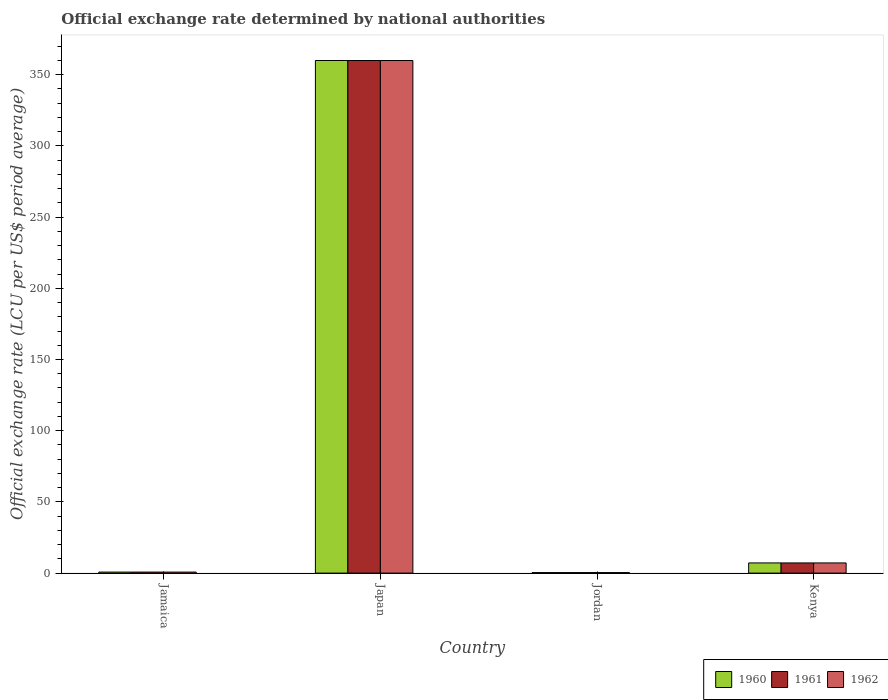How many different coloured bars are there?
Make the answer very short. 3. How many groups of bars are there?
Offer a terse response. 4. Are the number of bars on each tick of the X-axis equal?
Provide a succinct answer. Yes. How many bars are there on the 2nd tick from the right?
Provide a short and direct response. 3. What is the label of the 3rd group of bars from the left?
Make the answer very short. Jordan. In how many cases, is the number of bars for a given country not equal to the number of legend labels?
Your answer should be very brief. 0. What is the official exchange rate in 1962 in Jamaica?
Keep it short and to the point. 0.71. Across all countries, what is the maximum official exchange rate in 1960?
Give a very brief answer. 360. Across all countries, what is the minimum official exchange rate in 1961?
Keep it short and to the point. 0.36. In which country was the official exchange rate in 1962 minimum?
Provide a succinct answer. Jordan. What is the total official exchange rate in 1962 in the graph?
Keep it short and to the point. 368.21. What is the difference between the official exchange rate in 1960 in Jordan and that in Kenya?
Make the answer very short. -6.79. What is the difference between the official exchange rate in 1962 in Kenya and the official exchange rate in 1961 in Jordan?
Your answer should be compact. 6.79. What is the average official exchange rate in 1960 per country?
Offer a terse response. 92.05. What is the difference between the official exchange rate of/in 1962 and official exchange rate of/in 1960 in Jamaica?
Your answer should be very brief. 0. What is the ratio of the official exchange rate in 1961 in Japan to that in Jordan?
Give a very brief answer. 1008. Is the official exchange rate in 1961 in Jamaica less than that in Kenya?
Your answer should be very brief. Yes. What is the difference between the highest and the second highest official exchange rate in 1960?
Your answer should be compact. 359.29. What is the difference between the highest and the lowest official exchange rate in 1961?
Your response must be concise. 359.64. Is it the case that in every country, the sum of the official exchange rate in 1962 and official exchange rate in 1961 is greater than the official exchange rate in 1960?
Your answer should be compact. Yes. How many bars are there?
Your response must be concise. 12. Are all the bars in the graph horizontal?
Offer a very short reply. No. How many countries are there in the graph?
Ensure brevity in your answer.  4. Does the graph contain any zero values?
Offer a very short reply. No. Where does the legend appear in the graph?
Offer a terse response. Bottom right. How many legend labels are there?
Give a very brief answer. 3. How are the legend labels stacked?
Keep it short and to the point. Horizontal. What is the title of the graph?
Ensure brevity in your answer.  Official exchange rate determined by national authorities. What is the label or title of the X-axis?
Your answer should be compact. Country. What is the label or title of the Y-axis?
Give a very brief answer. Official exchange rate (LCU per US$ period average). What is the Official exchange rate (LCU per US$ period average) of 1960 in Jamaica?
Provide a succinct answer. 0.71. What is the Official exchange rate (LCU per US$ period average) of 1961 in Jamaica?
Your response must be concise. 0.71. What is the Official exchange rate (LCU per US$ period average) of 1962 in Jamaica?
Ensure brevity in your answer.  0.71. What is the Official exchange rate (LCU per US$ period average) in 1960 in Japan?
Make the answer very short. 360. What is the Official exchange rate (LCU per US$ period average) in 1961 in Japan?
Give a very brief answer. 360. What is the Official exchange rate (LCU per US$ period average) in 1962 in Japan?
Provide a succinct answer. 360. What is the Official exchange rate (LCU per US$ period average) in 1960 in Jordan?
Make the answer very short. 0.36. What is the Official exchange rate (LCU per US$ period average) in 1961 in Jordan?
Offer a terse response. 0.36. What is the Official exchange rate (LCU per US$ period average) of 1962 in Jordan?
Keep it short and to the point. 0.36. What is the Official exchange rate (LCU per US$ period average) of 1960 in Kenya?
Give a very brief answer. 7.14. What is the Official exchange rate (LCU per US$ period average) in 1961 in Kenya?
Ensure brevity in your answer.  7.14. What is the Official exchange rate (LCU per US$ period average) of 1962 in Kenya?
Ensure brevity in your answer.  7.14. Across all countries, what is the maximum Official exchange rate (LCU per US$ period average) of 1960?
Offer a terse response. 360. Across all countries, what is the maximum Official exchange rate (LCU per US$ period average) in 1961?
Ensure brevity in your answer.  360. Across all countries, what is the maximum Official exchange rate (LCU per US$ period average) of 1962?
Make the answer very short. 360. Across all countries, what is the minimum Official exchange rate (LCU per US$ period average) in 1960?
Give a very brief answer. 0.36. Across all countries, what is the minimum Official exchange rate (LCU per US$ period average) in 1961?
Ensure brevity in your answer.  0.36. Across all countries, what is the minimum Official exchange rate (LCU per US$ period average) of 1962?
Offer a very short reply. 0.36. What is the total Official exchange rate (LCU per US$ period average) in 1960 in the graph?
Your answer should be compact. 368.21. What is the total Official exchange rate (LCU per US$ period average) in 1961 in the graph?
Offer a very short reply. 368.21. What is the total Official exchange rate (LCU per US$ period average) in 1962 in the graph?
Your answer should be very brief. 368.21. What is the difference between the Official exchange rate (LCU per US$ period average) in 1960 in Jamaica and that in Japan?
Your answer should be compact. -359.29. What is the difference between the Official exchange rate (LCU per US$ period average) in 1961 in Jamaica and that in Japan?
Provide a short and direct response. -359.29. What is the difference between the Official exchange rate (LCU per US$ period average) of 1962 in Jamaica and that in Japan?
Provide a succinct answer. -359.29. What is the difference between the Official exchange rate (LCU per US$ period average) of 1960 in Jamaica and that in Jordan?
Provide a short and direct response. 0.36. What is the difference between the Official exchange rate (LCU per US$ period average) in 1961 in Jamaica and that in Jordan?
Your answer should be compact. 0.36. What is the difference between the Official exchange rate (LCU per US$ period average) in 1962 in Jamaica and that in Jordan?
Your answer should be very brief. 0.36. What is the difference between the Official exchange rate (LCU per US$ period average) in 1960 in Jamaica and that in Kenya?
Ensure brevity in your answer.  -6.43. What is the difference between the Official exchange rate (LCU per US$ period average) of 1961 in Jamaica and that in Kenya?
Your answer should be compact. -6.43. What is the difference between the Official exchange rate (LCU per US$ period average) in 1962 in Jamaica and that in Kenya?
Give a very brief answer. -6.43. What is the difference between the Official exchange rate (LCU per US$ period average) in 1960 in Japan and that in Jordan?
Offer a terse response. 359.64. What is the difference between the Official exchange rate (LCU per US$ period average) of 1961 in Japan and that in Jordan?
Make the answer very short. 359.64. What is the difference between the Official exchange rate (LCU per US$ period average) in 1962 in Japan and that in Jordan?
Your answer should be compact. 359.64. What is the difference between the Official exchange rate (LCU per US$ period average) in 1960 in Japan and that in Kenya?
Make the answer very short. 352.86. What is the difference between the Official exchange rate (LCU per US$ period average) of 1961 in Japan and that in Kenya?
Offer a terse response. 352.86. What is the difference between the Official exchange rate (LCU per US$ period average) in 1962 in Japan and that in Kenya?
Your answer should be compact. 352.86. What is the difference between the Official exchange rate (LCU per US$ period average) in 1960 in Jordan and that in Kenya?
Ensure brevity in your answer.  -6.79. What is the difference between the Official exchange rate (LCU per US$ period average) of 1961 in Jordan and that in Kenya?
Make the answer very short. -6.79. What is the difference between the Official exchange rate (LCU per US$ period average) of 1962 in Jordan and that in Kenya?
Make the answer very short. -6.79. What is the difference between the Official exchange rate (LCU per US$ period average) of 1960 in Jamaica and the Official exchange rate (LCU per US$ period average) of 1961 in Japan?
Provide a short and direct response. -359.29. What is the difference between the Official exchange rate (LCU per US$ period average) in 1960 in Jamaica and the Official exchange rate (LCU per US$ period average) in 1962 in Japan?
Provide a short and direct response. -359.29. What is the difference between the Official exchange rate (LCU per US$ period average) in 1961 in Jamaica and the Official exchange rate (LCU per US$ period average) in 1962 in Japan?
Your response must be concise. -359.29. What is the difference between the Official exchange rate (LCU per US$ period average) of 1960 in Jamaica and the Official exchange rate (LCU per US$ period average) of 1961 in Jordan?
Make the answer very short. 0.36. What is the difference between the Official exchange rate (LCU per US$ period average) in 1960 in Jamaica and the Official exchange rate (LCU per US$ period average) in 1962 in Jordan?
Provide a short and direct response. 0.36. What is the difference between the Official exchange rate (LCU per US$ period average) of 1961 in Jamaica and the Official exchange rate (LCU per US$ period average) of 1962 in Jordan?
Give a very brief answer. 0.36. What is the difference between the Official exchange rate (LCU per US$ period average) of 1960 in Jamaica and the Official exchange rate (LCU per US$ period average) of 1961 in Kenya?
Give a very brief answer. -6.43. What is the difference between the Official exchange rate (LCU per US$ period average) in 1960 in Jamaica and the Official exchange rate (LCU per US$ period average) in 1962 in Kenya?
Your response must be concise. -6.43. What is the difference between the Official exchange rate (LCU per US$ period average) of 1961 in Jamaica and the Official exchange rate (LCU per US$ period average) of 1962 in Kenya?
Provide a short and direct response. -6.43. What is the difference between the Official exchange rate (LCU per US$ period average) in 1960 in Japan and the Official exchange rate (LCU per US$ period average) in 1961 in Jordan?
Offer a very short reply. 359.64. What is the difference between the Official exchange rate (LCU per US$ period average) of 1960 in Japan and the Official exchange rate (LCU per US$ period average) of 1962 in Jordan?
Your response must be concise. 359.64. What is the difference between the Official exchange rate (LCU per US$ period average) in 1961 in Japan and the Official exchange rate (LCU per US$ period average) in 1962 in Jordan?
Provide a short and direct response. 359.64. What is the difference between the Official exchange rate (LCU per US$ period average) in 1960 in Japan and the Official exchange rate (LCU per US$ period average) in 1961 in Kenya?
Ensure brevity in your answer.  352.86. What is the difference between the Official exchange rate (LCU per US$ period average) in 1960 in Japan and the Official exchange rate (LCU per US$ period average) in 1962 in Kenya?
Your answer should be compact. 352.86. What is the difference between the Official exchange rate (LCU per US$ period average) of 1961 in Japan and the Official exchange rate (LCU per US$ period average) of 1962 in Kenya?
Provide a succinct answer. 352.86. What is the difference between the Official exchange rate (LCU per US$ period average) of 1960 in Jordan and the Official exchange rate (LCU per US$ period average) of 1961 in Kenya?
Your response must be concise. -6.79. What is the difference between the Official exchange rate (LCU per US$ period average) in 1960 in Jordan and the Official exchange rate (LCU per US$ period average) in 1962 in Kenya?
Offer a very short reply. -6.79. What is the difference between the Official exchange rate (LCU per US$ period average) in 1961 in Jordan and the Official exchange rate (LCU per US$ period average) in 1962 in Kenya?
Provide a short and direct response. -6.79. What is the average Official exchange rate (LCU per US$ period average) in 1960 per country?
Provide a succinct answer. 92.05. What is the average Official exchange rate (LCU per US$ period average) in 1961 per country?
Your answer should be compact. 92.05. What is the average Official exchange rate (LCU per US$ period average) of 1962 per country?
Provide a short and direct response. 92.05. What is the difference between the Official exchange rate (LCU per US$ period average) in 1960 and Official exchange rate (LCU per US$ period average) in 1961 in Jamaica?
Give a very brief answer. 0. What is the difference between the Official exchange rate (LCU per US$ period average) of 1960 and Official exchange rate (LCU per US$ period average) of 1962 in Jamaica?
Give a very brief answer. 0. What is the difference between the Official exchange rate (LCU per US$ period average) in 1961 and Official exchange rate (LCU per US$ period average) in 1962 in Jamaica?
Offer a terse response. 0. What is the difference between the Official exchange rate (LCU per US$ period average) in 1960 and Official exchange rate (LCU per US$ period average) in 1961 in Japan?
Your answer should be very brief. 0. What is the difference between the Official exchange rate (LCU per US$ period average) of 1960 and Official exchange rate (LCU per US$ period average) of 1962 in Japan?
Provide a short and direct response. 0. What is the difference between the Official exchange rate (LCU per US$ period average) in 1961 and Official exchange rate (LCU per US$ period average) in 1962 in Japan?
Your answer should be very brief. 0. What is the difference between the Official exchange rate (LCU per US$ period average) of 1961 and Official exchange rate (LCU per US$ period average) of 1962 in Jordan?
Provide a short and direct response. 0. What is the difference between the Official exchange rate (LCU per US$ period average) in 1960 and Official exchange rate (LCU per US$ period average) in 1962 in Kenya?
Your answer should be compact. 0. What is the difference between the Official exchange rate (LCU per US$ period average) in 1961 and Official exchange rate (LCU per US$ period average) in 1962 in Kenya?
Make the answer very short. 0. What is the ratio of the Official exchange rate (LCU per US$ period average) in 1960 in Jamaica to that in Japan?
Your answer should be compact. 0. What is the ratio of the Official exchange rate (LCU per US$ period average) in 1961 in Jamaica to that in Japan?
Your answer should be compact. 0. What is the ratio of the Official exchange rate (LCU per US$ period average) of 1962 in Jamaica to that in Japan?
Offer a very short reply. 0. What is the ratio of the Official exchange rate (LCU per US$ period average) in 1960 in Jamaica to that in Kenya?
Provide a short and direct response. 0.1. What is the ratio of the Official exchange rate (LCU per US$ period average) of 1961 in Jamaica to that in Kenya?
Offer a very short reply. 0.1. What is the ratio of the Official exchange rate (LCU per US$ period average) in 1962 in Jamaica to that in Kenya?
Your answer should be very brief. 0.1. What is the ratio of the Official exchange rate (LCU per US$ period average) in 1960 in Japan to that in Jordan?
Give a very brief answer. 1008. What is the ratio of the Official exchange rate (LCU per US$ period average) of 1961 in Japan to that in Jordan?
Give a very brief answer. 1008. What is the ratio of the Official exchange rate (LCU per US$ period average) of 1962 in Japan to that in Jordan?
Provide a succinct answer. 1008. What is the ratio of the Official exchange rate (LCU per US$ period average) in 1960 in Japan to that in Kenya?
Offer a very short reply. 50.4. What is the ratio of the Official exchange rate (LCU per US$ period average) of 1961 in Japan to that in Kenya?
Offer a very short reply. 50.4. What is the ratio of the Official exchange rate (LCU per US$ period average) of 1962 in Japan to that in Kenya?
Offer a very short reply. 50.4. What is the ratio of the Official exchange rate (LCU per US$ period average) in 1960 in Jordan to that in Kenya?
Your response must be concise. 0.05. What is the ratio of the Official exchange rate (LCU per US$ period average) of 1962 in Jordan to that in Kenya?
Provide a short and direct response. 0.05. What is the difference between the highest and the second highest Official exchange rate (LCU per US$ period average) of 1960?
Offer a very short reply. 352.86. What is the difference between the highest and the second highest Official exchange rate (LCU per US$ period average) in 1961?
Offer a terse response. 352.86. What is the difference between the highest and the second highest Official exchange rate (LCU per US$ period average) in 1962?
Give a very brief answer. 352.86. What is the difference between the highest and the lowest Official exchange rate (LCU per US$ period average) in 1960?
Offer a terse response. 359.64. What is the difference between the highest and the lowest Official exchange rate (LCU per US$ period average) in 1961?
Offer a terse response. 359.64. What is the difference between the highest and the lowest Official exchange rate (LCU per US$ period average) in 1962?
Give a very brief answer. 359.64. 